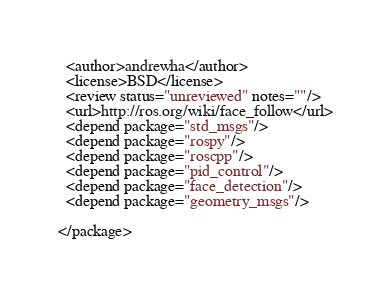Convert code to text. <code><loc_0><loc_0><loc_500><loc_500><_XML_>  <author>andrewha</author>
  <license>BSD</license>
  <review status="unreviewed" notes=""/>
  <url>http://ros.org/wiki/face_follow</url>
  <depend package="std_msgs"/>
  <depend package="rospy"/>
  <depend package="roscpp"/>
  <depend package="pid_control"/>
  <depend package="face_detection"/>
  <depend package="geometry_msgs"/>

</package>


</code> 